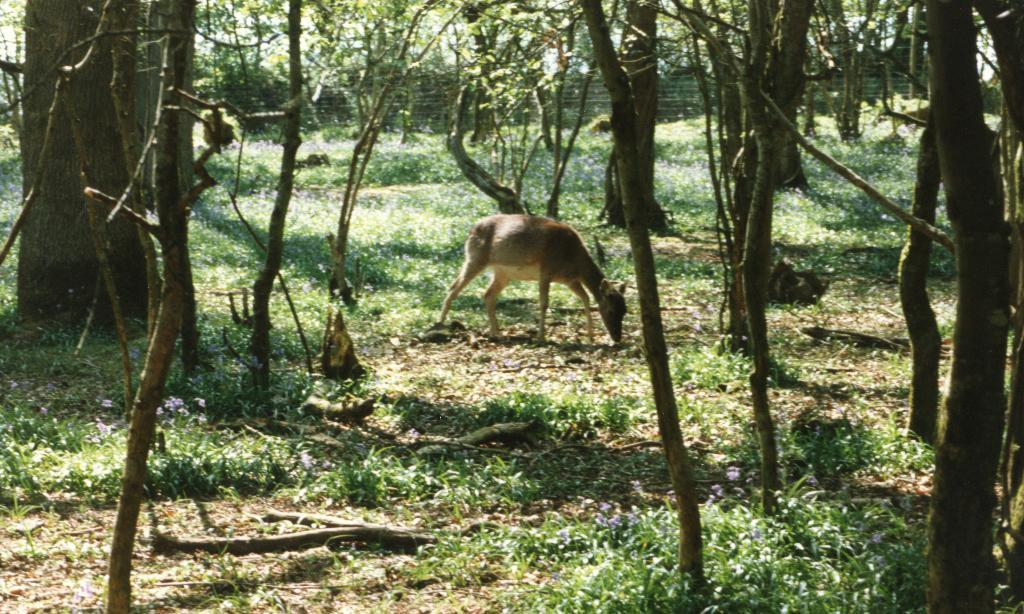What animal can be seen in the image? There is a deer in the image. What is the deer standing on? The deer is standing on the grass. Where is the deer located in relation to the trees? The deer is between trees. Is there a stream visible in the image? There is no stream present in the image. 